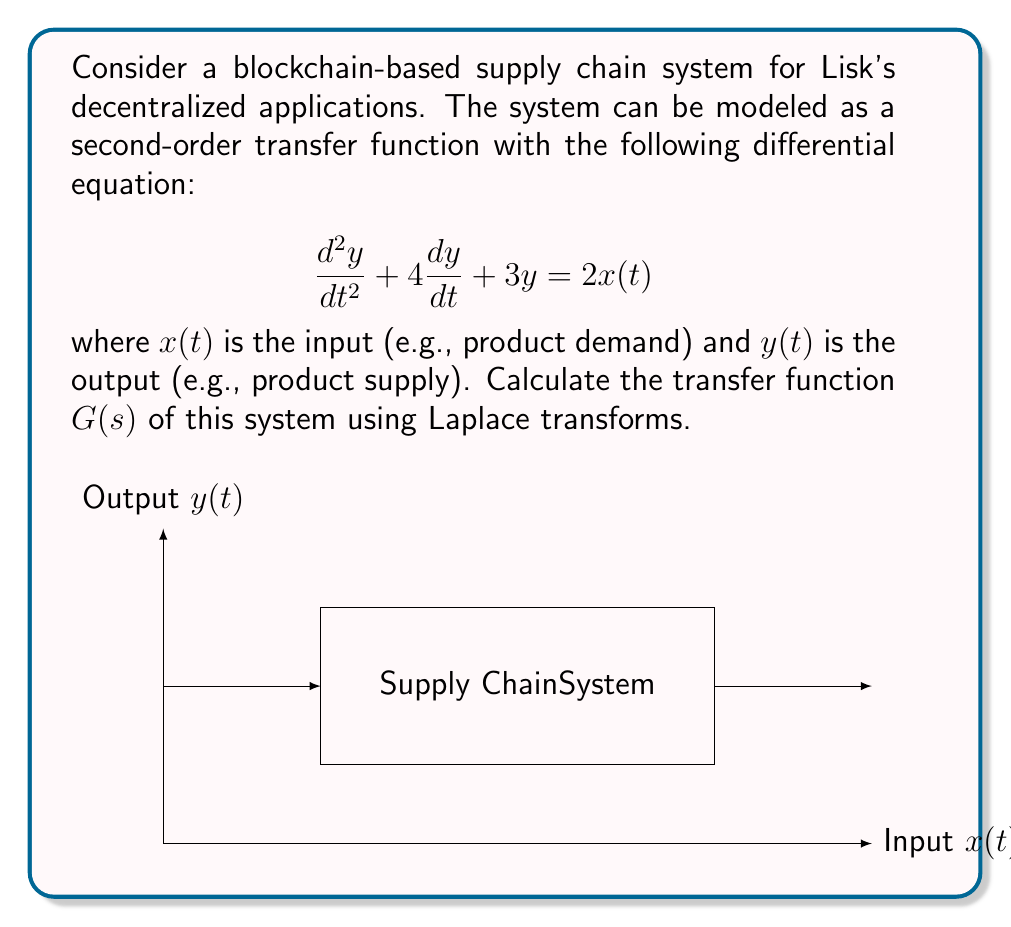Give your solution to this math problem. To find the transfer function using Laplace transforms, we follow these steps:

1) Take the Laplace transform of both sides of the differential equation:
   $$\mathcal{L}\left\{\frac{d^2y}{dt^2} + 4\frac{dy}{dt} + 3y\right\} = \mathcal{L}\{2x(t)\}$$

2) Apply Laplace transform properties:
   $$s^2Y(s) - sy(0) - y'(0) + 4[sY(s) - y(0)] + 3Y(s) = 2X(s)$$

3) Assume zero initial conditions: $y(0) = y'(0) = 0$
   $$s^2Y(s) + 4sY(s) + 3Y(s) = 2X(s)$$

4) Factor out $Y(s)$:
   $$(s^2 + 4s + 3)Y(s) = 2X(s)$$

5) Solve for $Y(s)/X(s)$, which is the transfer function $G(s)$:
   $$G(s) = \frac{Y(s)}{X(s)} = \frac{2}{s^2 + 4s + 3}$$

6) Simplify if needed (in this case, it's already in its simplest form)

Thus, the transfer function of the blockchain-based supply chain system is $G(s) = \frac{2}{s^2 + 4s + 3}$.
Answer: $$G(s) = \frac{2}{s^2 + 4s + 3}$$ 